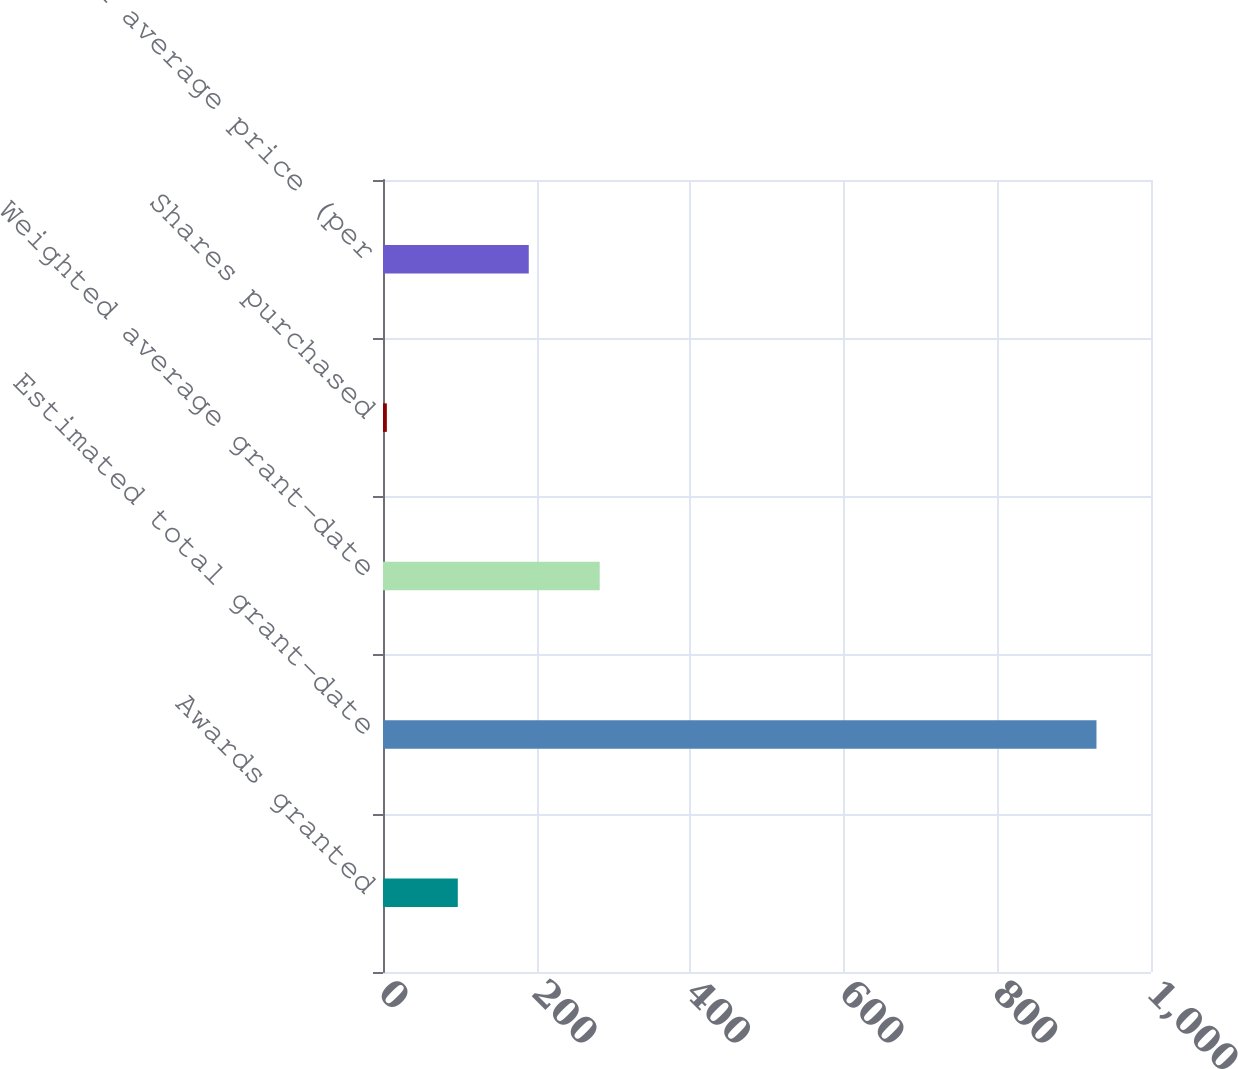Convert chart. <chart><loc_0><loc_0><loc_500><loc_500><bar_chart><fcel>Awards granted<fcel>Estimated total grant-date<fcel>Weighted average grant-date<fcel>Shares purchased<fcel>Weighted average price (per<nl><fcel>97.4<fcel>929<fcel>282.2<fcel>5<fcel>189.8<nl></chart> 